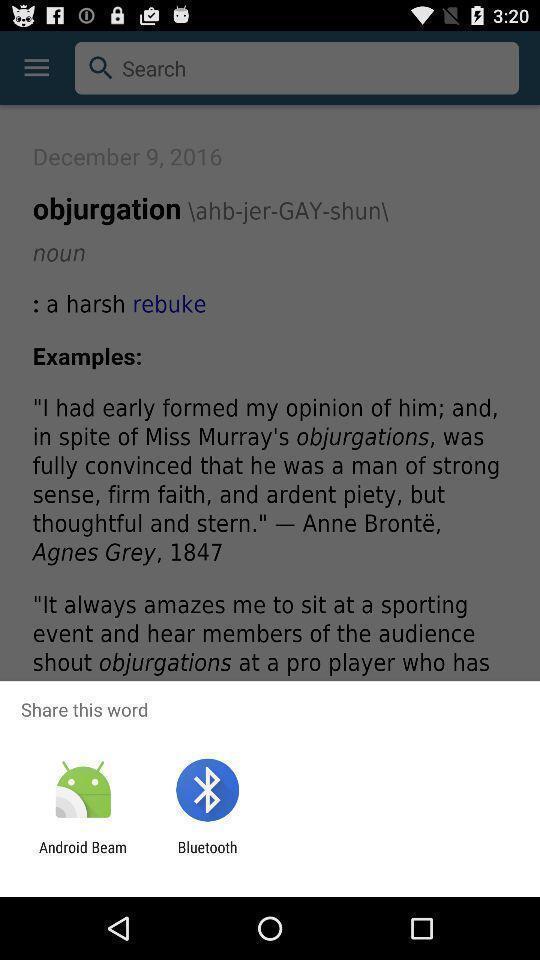Tell me about the visual elements in this screen capture. Screen shows share option with multiple applications. 